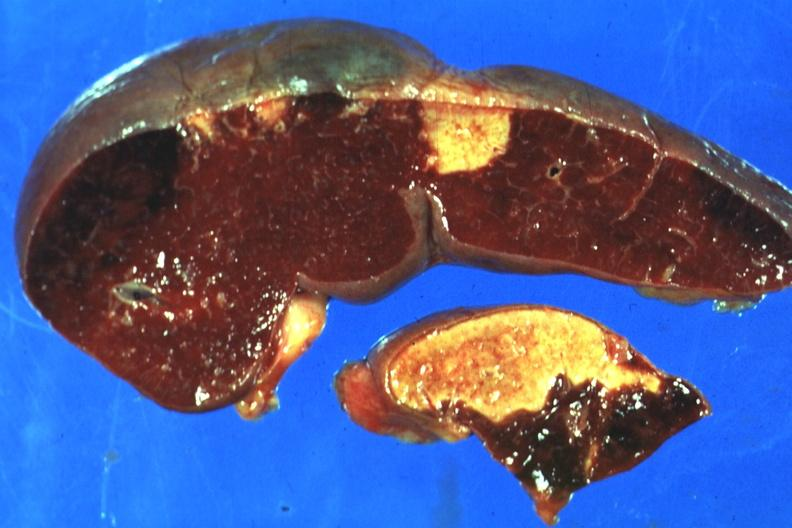s squamous cell carcinoma, lip remote, present?
Answer the question using a single word or phrase. No 